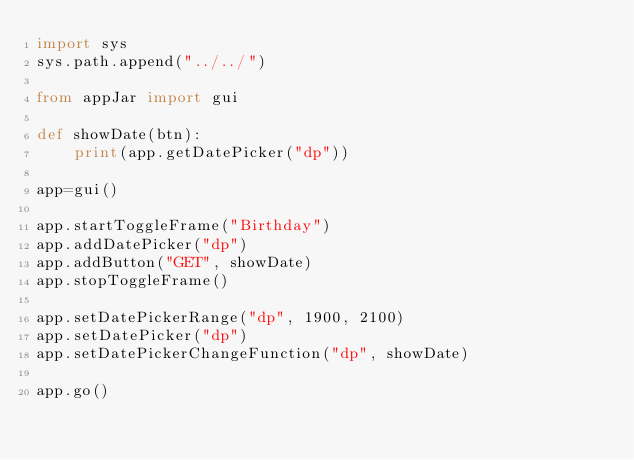Convert code to text. <code><loc_0><loc_0><loc_500><loc_500><_Python_>import sys
sys.path.append("../../")

from appJar import gui

def showDate(btn):
    print(app.getDatePicker("dp"))

app=gui()

app.startToggleFrame("Birthday")
app.addDatePicker("dp")
app.addButton("GET", showDate)
app.stopToggleFrame()

app.setDatePickerRange("dp", 1900, 2100)
app.setDatePicker("dp")
app.setDatePickerChangeFunction("dp", showDate)

app.go()
</code> 